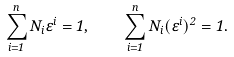Convert formula to latex. <formula><loc_0><loc_0><loc_500><loc_500>\sum _ { i = 1 } ^ { n } N _ { i } \varepsilon ^ { i } = 1 , \quad \sum _ { i = 1 } ^ { n } N _ { i } ( \varepsilon ^ { i } ) ^ { 2 } = 1 .</formula> 